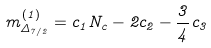Convert formula to latex. <formula><loc_0><loc_0><loc_500><loc_500>m ^ { ( 1 ) } _ { \Delta _ { 7 / 2 } } = c _ { 1 } N _ { c } - 2 c _ { 2 } - \frac { 3 } { 4 } c _ { 3 }</formula> 